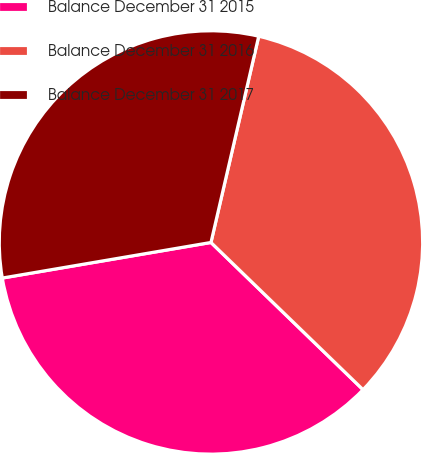Convert chart to OTSL. <chart><loc_0><loc_0><loc_500><loc_500><pie_chart><fcel>Balance December 31 2015<fcel>Balance December 31 2016<fcel>Balance December 31 2017<nl><fcel>35.07%<fcel>33.62%<fcel>31.31%<nl></chart> 